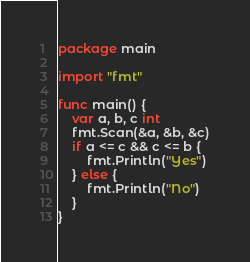Convert code to text. <code><loc_0><loc_0><loc_500><loc_500><_Go_>package main

import "fmt"

func main() {
	var a, b, c int
	fmt.Scan(&a, &b, &c)
	if a <= c && c <= b {
		fmt.Println("Yes")
	} else {
		fmt.Println("No")
	}
}
</code> 